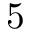<formula> <loc_0><loc_0><loc_500><loc_500>5</formula> 